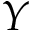Convert formula to latex. <formula><loc_0><loc_0><loc_500><loc_500>Y</formula> 